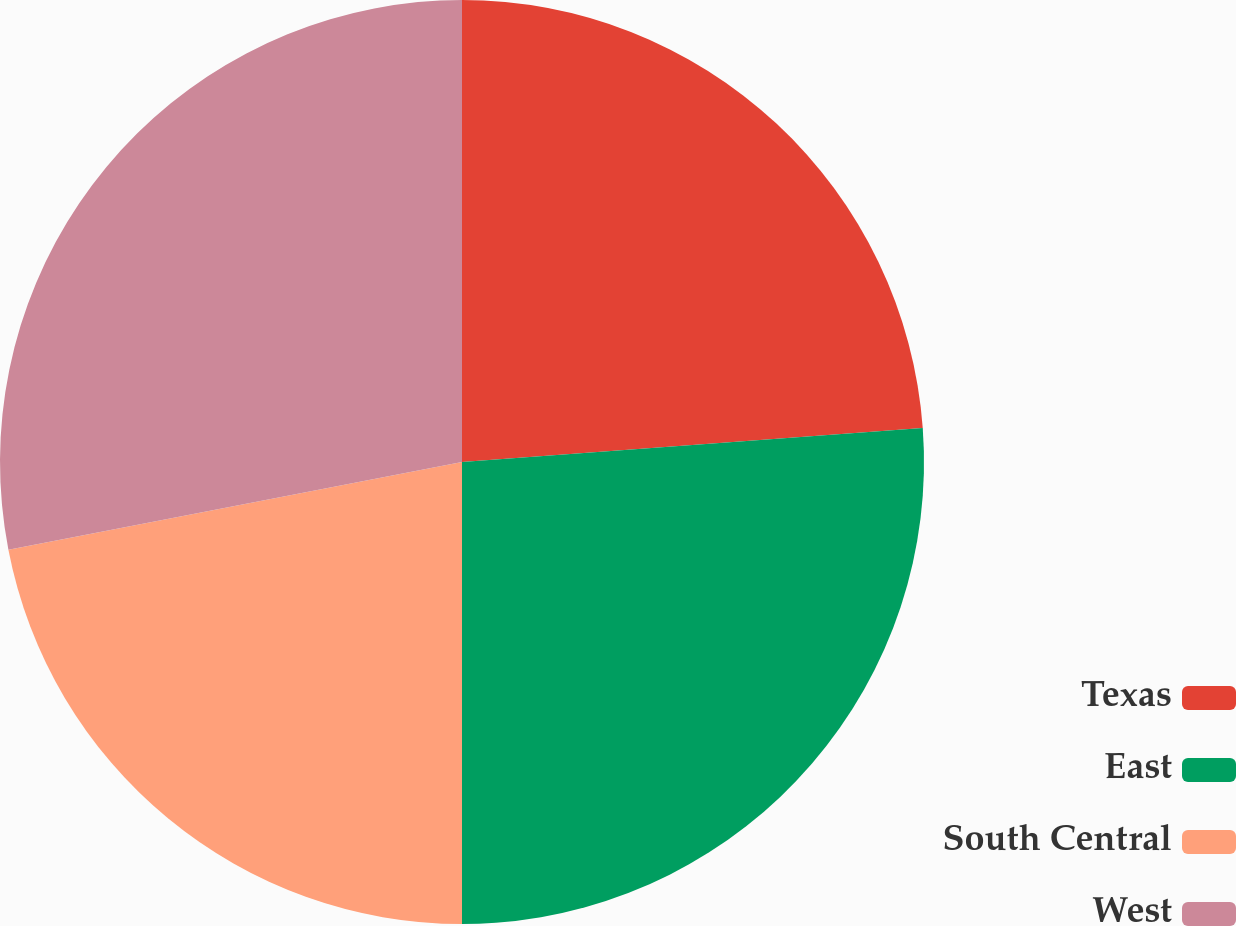Convert chart to OTSL. <chart><loc_0><loc_0><loc_500><loc_500><pie_chart><fcel>Texas<fcel>East<fcel>South Central<fcel>West<nl><fcel>23.83%<fcel>26.17%<fcel>21.96%<fcel>28.04%<nl></chart> 